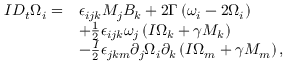<formula> <loc_0><loc_0><loc_500><loc_500>\begin{array} { r l } { I D _ { t } \Omega _ { i } = } & { \epsilon _ { i j k } M _ { j } B _ { k } + 2 \Gamma \left ( \omega _ { i } - 2 \Omega _ { i } \right ) } \\ & { + \frac { 1 } { 2 } \epsilon _ { i j k } \omega _ { j } \left ( I \Omega _ { k } + \gamma M _ { k } \right ) } \\ & { - \frac { I } { 2 } \epsilon _ { j k m } \partial _ { j } \Omega _ { i } \partial _ { k } \left ( I \Omega _ { m } + \gamma M _ { m } \right ) , } \end{array}</formula> 